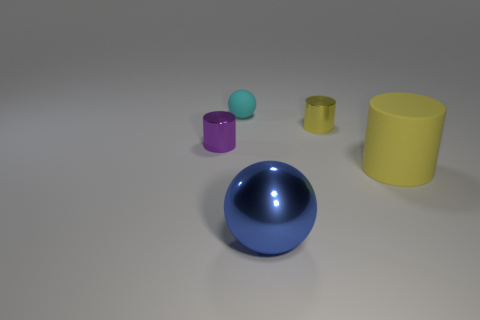Add 1 big blue metallic things. How many objects exist? 6 Subtract all balls. How many objects are left? 3 Add 5 metallic cylinders. How many metallic cylinders exist? 7 Subtract 0 green cylinders. How many objects are left? 5 Subtract all tiny brown matte spheres. Subtract all yellow cylinders. How many objects are left? 3 Add 5 purple metallic cylinders. How many purple metallic cylinders are left? 6 